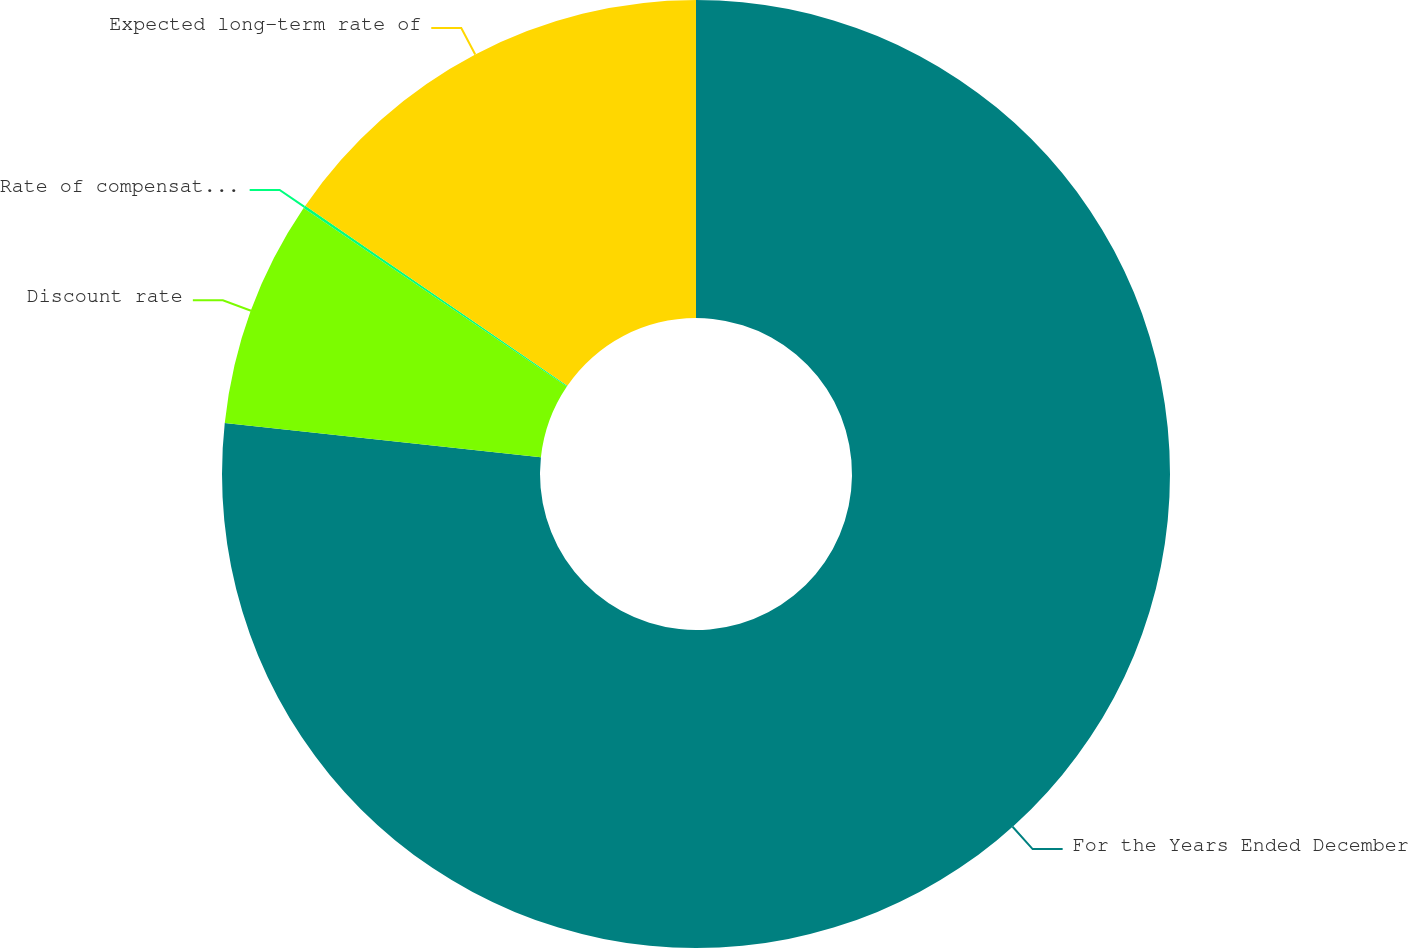<chart> <loc_0><loc_0><loc_500><loc_500><pie_chart><fcel>For the Years Ended December<fcel>Discount rate<fcel>Rate of compensation increase<fcel>Expected long-term rate of<nl><fcel>76.71%<fcel>7.76%<fcel>0.1%<fcel>15.42%<nl></chart> 